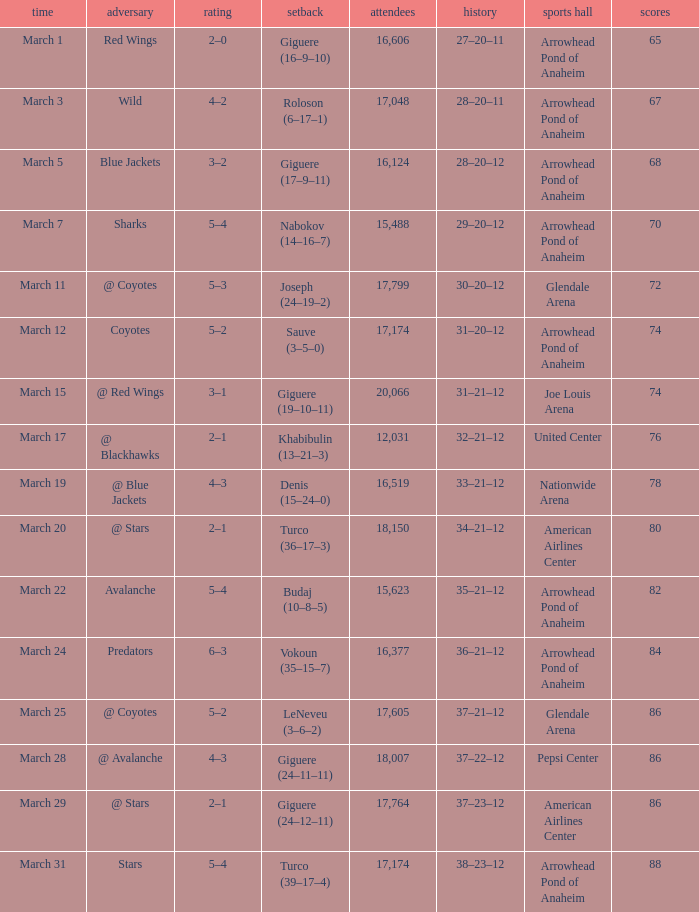What is the Attendance of the game with a Record of 37–21–12 and less than 86 Points? None. 